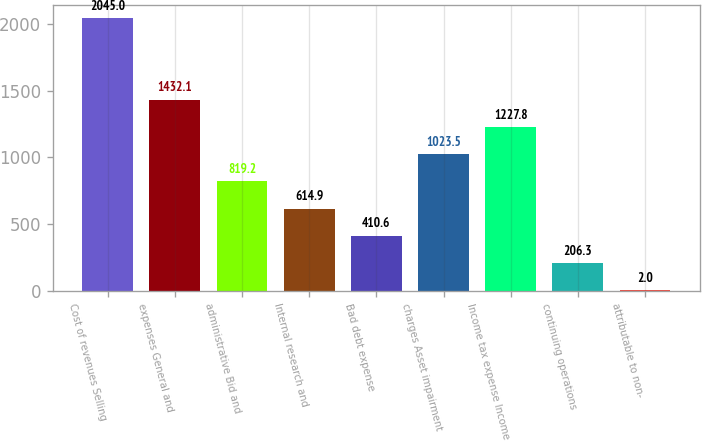Convert chart to OTSL. <chart><loc_0><loc_0><loc_500><loc_500><bar_chart><fcel>Cost of revenues Selling<fcel>expenses General and<fcel>administrative Bid and<fcel>Internal research and<fcel>Bad debt expense<fcel>charges Asset impairment<fcel>Income tax expense Income<fcel>continuing operations<fcel>attributable to non-<nl><fcel>2045<fcel>1432.1<fcel>819.2<fcel>614.9<fcel>410.6<fcel>1023.5<fcel>1227.8<fcel>206.3<fcel>2<nl></chart> 